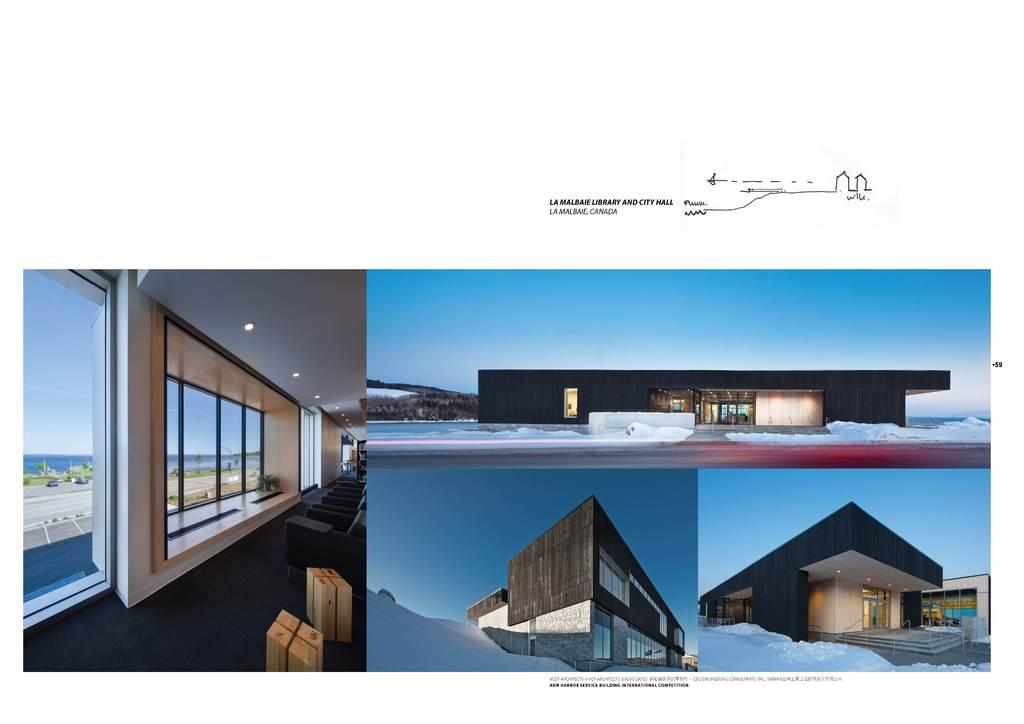What type of openings can be seen in the image? There are windows in the image. What part of the natural environment is visible in the image? The sky is visible in the image. What type of structure is present in the image? There is a building in the image. What type of weather condition is depicted in the image? There is snow in the image. What type of vegetation is visible in the image? There are trees in the image. What type of holiday is being celebrated in the image? There is no indication of a holiday being celebrated in the image. What type of books or reading material can be seen in the image? There are no books or reading material present in the image. 